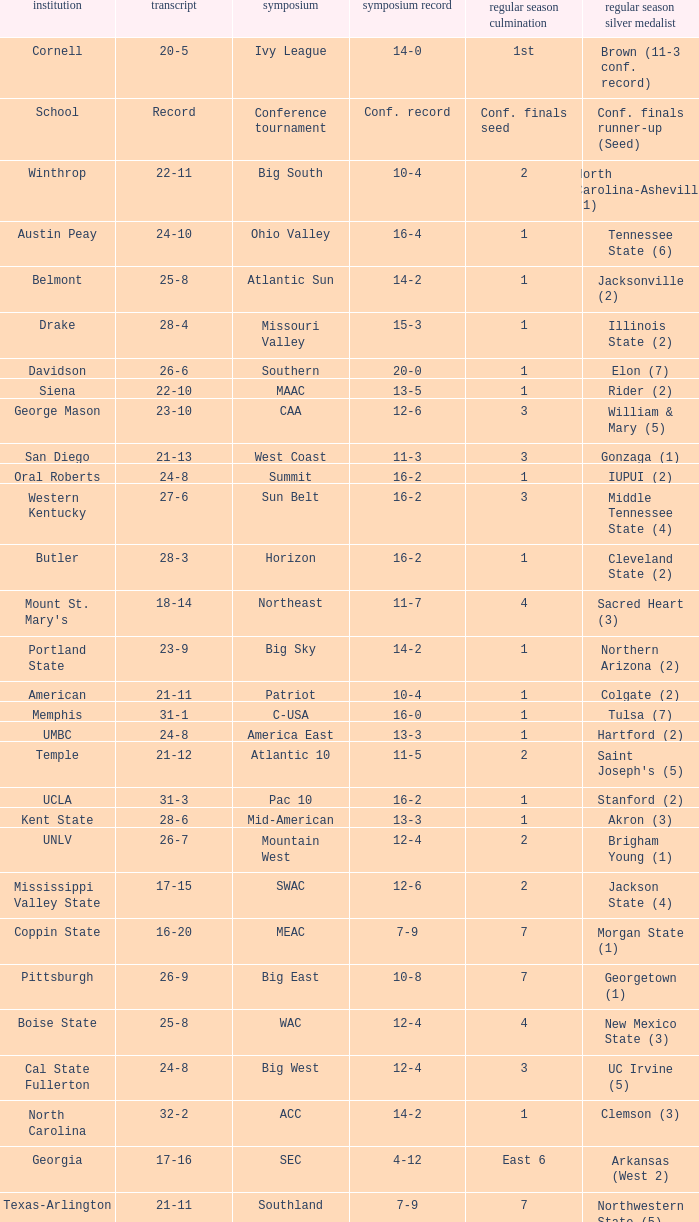What was the overall record of UMBC? 24-8. 